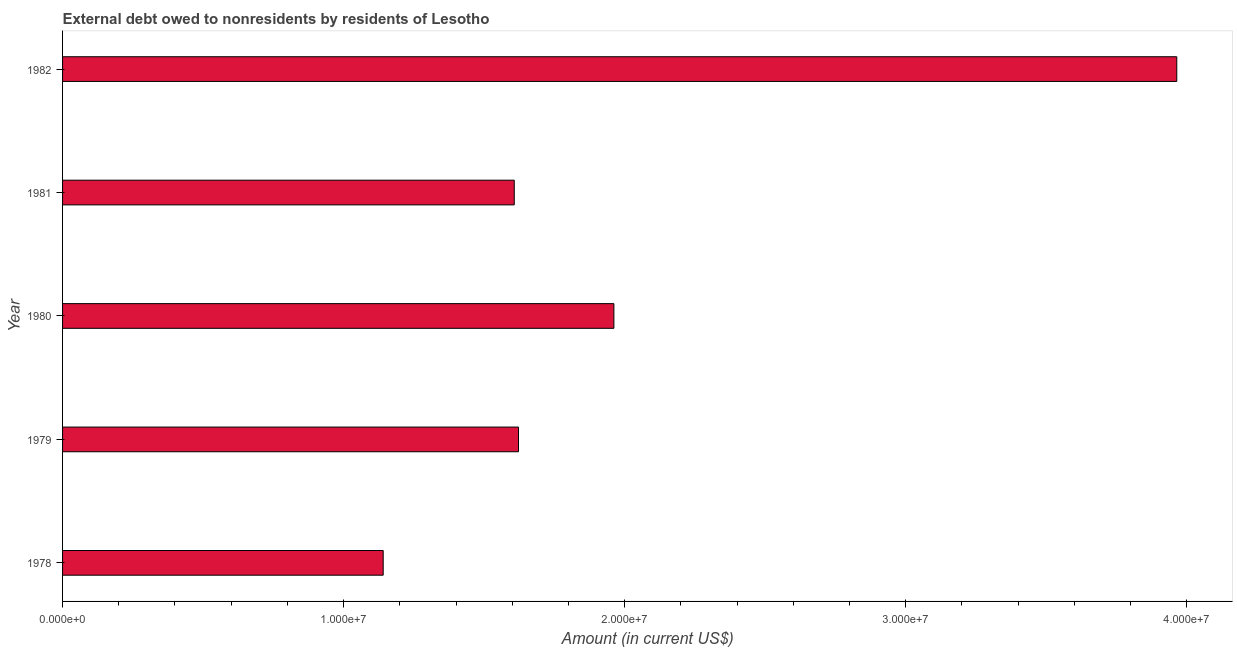Does the graph contain any zero values?
Your response must be concise. No. What is the title of the graph?
Your answer should be very brief. External debt owed to nonresidents by residents of Lesotho. What is the debt in 1982?
Offer a very short reply. 3.96e+07. Across all years, what is the maximum debt?
Your answer should be compact. 3.96e+07. Across all years, what is the minimum debt?
Provide a short and direct response. 1.14e+07. In which year was the debt maximum?
Your response must be concise. 1982. In which year was the debt minimum?
Your answer should be very brief. 1978. What is the sum of the debt?
Offer a terse response. 1.03e+08. What is the difference between the debt in 1980 and 1982?
Your answer should be compact. -2.00e+07. What is the average debt per year?
Provide a short and direct response. 2.06e+07. What is the median debt?
Your answer should be compact. 1.62e+07. In how many years, is the debt greater than 20000000 US$?
Provide a succinct answer. 1. Do a majority of the years between 1981 and 1978 (inclusive) have debt greater than 6000000 US$?
Offer a very short reply. Yes. What is the ratio of the debt in 1981 to that in 1982?
Make the answer very short. 0.41. Is the debt in 1978 less than that in 1982?
Keep it short and to the point. Yes. What is the difference between the highest and the second highest debt?
Make the answer very short. 2.00e+07. What is the difference between the highest and the lowest debt?
Provide a succinct answer. 2.82e+07. In how many years, is the debt greater than the average debt taken over all years?
Provide a short and direct response. 1. How many bars are there?
Keep it short and to the point. 5. Are all the bars in the graph horizontal?
Keep it short and to the point. Yes. How many years are there in the graph?
Your response must be concise. 5. Are the values on the major ticks of X-axis written in scientific E-notation?
Offer a very short reply. Yes. What is the Amount (in current US$) in 1978?
Provide a succinct answer. 1.14e+07. What is the Amount (in current US$) of 1979?
Give a very brief answer. 1.62e+07. What is the Amount (in current US$) of 1980?
Your response must be concise. 1.96e+07. What is the Amount (in current US$) in 1981?
Keep it short and to the point. 1.61e+07. What is the Amount (in current US$) in 1982?
Make the answer very short. 3.96e+07. What is the difference between the Amount (in current US$) in 1978 and 1979?
Ensure brevity in your answer.  -4.81e+06. What is the difference between the Amount (in current US$) in 1978 and 1980?
Provide a short and direct response. -8.21e+06. What is the difference between the Amount (in current US$) in 1978 and 1981?
Offer a very short reply. -4.66e+06. What is the difference between the Amount (in current US$) in 1978 and 1982?
Ensure brevity in your answer.  -2.82e+07. What is the difference between the Amount (in current US$) in 1979 and 1980?
Make the answer very short. -3.39e+06. What is the difference between the Amount (in current US$) in 1979 and 1981?
Your answer should be compact. 1.51e+05. What is the difference between the Amount (in current US$) in 1979 and 1982?
Keep it short and to the point. -2.34e+07. What is the difference between the Amount (in current US$) in 1980 and 1981?
Offer a very short reply. 3.54e+06. What is the difference between the Amount (in current US$) in 1980 and 1982?
Your response must be concise. -2.00e+07. What is the difference between the Amount (in current US$) in 1981 and 1982?
Make the answer very short. -2.36e+07. What is the ratio of the Amount (in current US$) in 1978 to that in 1979?
Your answer should be compact. 0.7. What is the ratio of the Amount (in current US$) in 1978 to that in 1980?
Keep it short and to the point. 0.58. What is the ratio of the Amount (in current US$) in 1978 to that in 1981?
Provide a succinct answer. 0.71. What is the ratio of the Amount (in current US$) in 1978 to that in 1982?
Provide a succinct answer. 0.29. What is the ratio of the Amount (in current US$) in 1979 to that in 1980?
Make the answer very short. 0.83. What is the ratio of the Amount (in current US$) in 1979 to that in 1981?
Make the answer very short. 1.01. What is the ratio of the Amount (in current US$) in 1979 to that in 1982?
Provide a succinct answer. 0.41. What is the ratio of the Amount (in current US$) in 1980 to that in 1981?
Give a very brief answer. 1.22. What is the ratio of the Amount (in current US$) in 1980 to that in 1982?
Make the answer very short. 0.49. What is the ratio of the Amount (in current US$) in 1981 to that in 1982?
Provide a short and direct response. 0.41. 